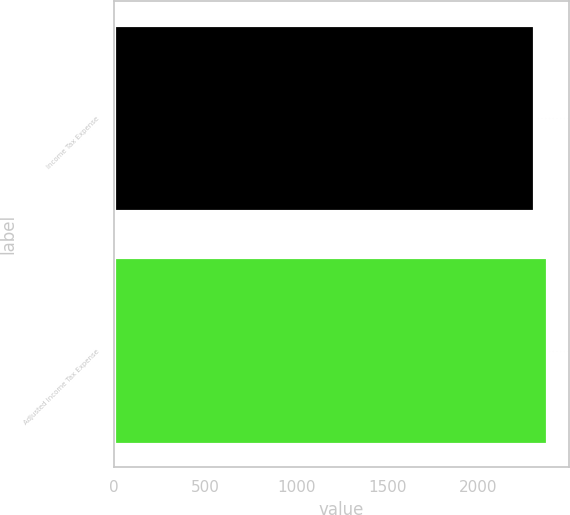Convert chart to OTSL. <chart><loc_0><loc_0><loc_500><loc_500><bar_chart><fcel>Income Tax Expense<fcel>Adjusted Income Tax Expense<nl><fcel>2302<fcel>2377<nl></chart> 